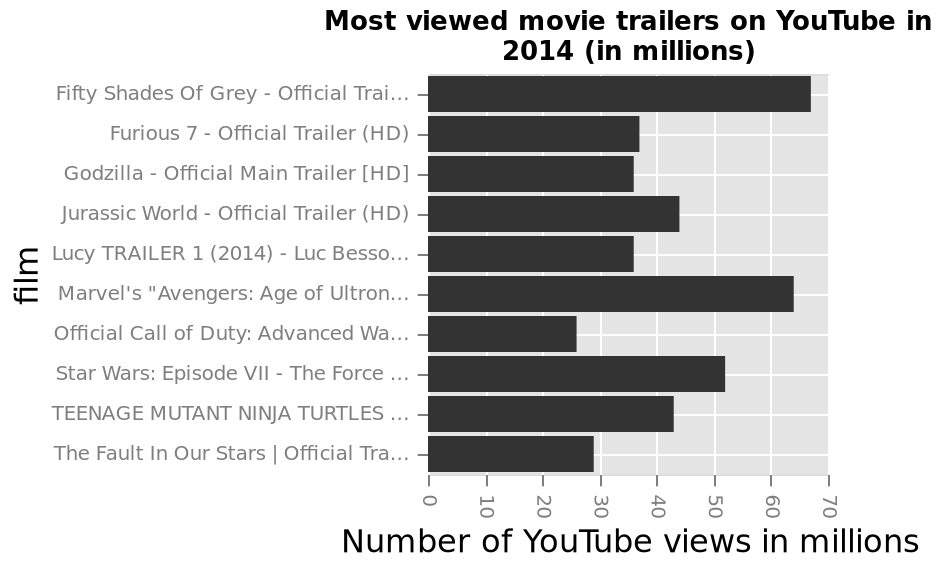<image>
How many views does Fifty Shades of Grey have? More than 60 million views. 